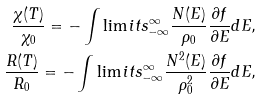Convert formula to latex. <formula><loc_0><loc_0><loc_500><loc_500>\frac { \chi ( T ) } { \chi _ { 0 } } = - \int \lim i t s _ { - \infty } ^ { \infty } \frac { N ( E ) } { \rho _ { 0 } } \frac { \partial f } { \partial E } d E , \\ \frac { R ( T ) } { R _ { 0 } } = - \int \lim i t s _ { - \infty } ^ { \infty } \frac { N ^ { 2 } ( E ) } { \rho _ { 0 } ^ { 2 } } \frac { \partial f } { \partial E } d E ,</formula> 